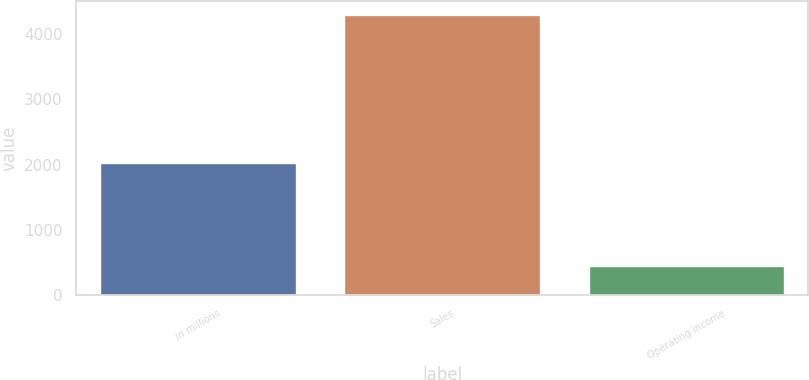Convert chart. <chart><loc_0><loc_0><loc_500><loc_500><bar_chart><fcel>in millions<fcel>Sales<fcel>Operating income<nl><fcel>2018<fcel>4297<fcel>443<nl></chart> 